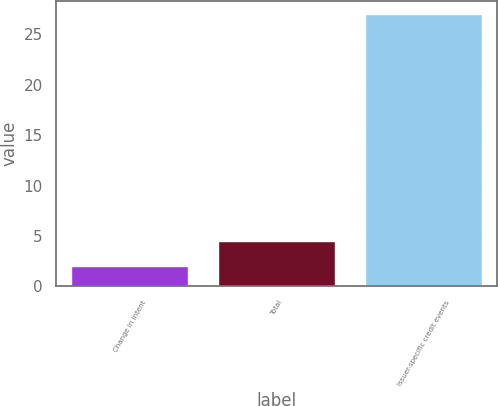Convert chart. <chart><loc_0><loc_0><loc_500><loc_500><bar_chart><fcel>Change in intent<fcel>Total<fcel>Issuer-specific credit events<nl><fcel>2<fcel>4.5<fcel>27<nl></chart> 